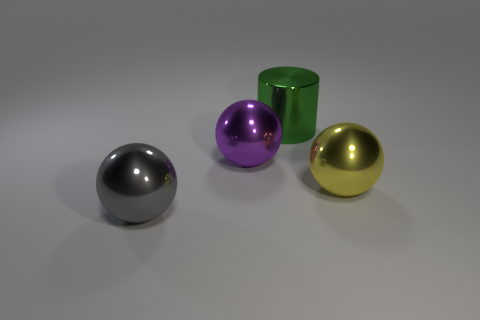There is a gray object that is in front of the large purple metallic ball; what is its shape?
Provide a short and direct response. Sphere. Is the number of objects that are behind the big yellow sphere less than the number of shiny objects that are in front of the cylinder?
Give a very brief answer. Yes. What is the shape of the gray object?
Your response must be concise. Sphere. Are there more large yellow metal objects right of the purple ball than large cylinders left of the big gray thing?
Your response must be concise. Yes. Does the object to the left of the big purple sphere have the same shape as the yellow metallic object right of the purple object?
Give a very brief answer. Yes. Are there any large yellow metal objects on the left side of the big purple shiny sphere?
Your answer should be very brief. No. There is a large metal object that is both behind the big yellow metallic sphere and on the left side of the big green cylinder; what color is it?
Provide a short and direct response. Purple. There is a cylinder that is behind the ball that is behind the big yellow metal object; what is its size?
Offer a terse response. Large. What number of cylinders are big green objects or yellow metallic objects?
Provide a short and direct response. 1. There is a cylinder that is the same size as the yellow thing; what is its color?
Your response must be concise. Green. 